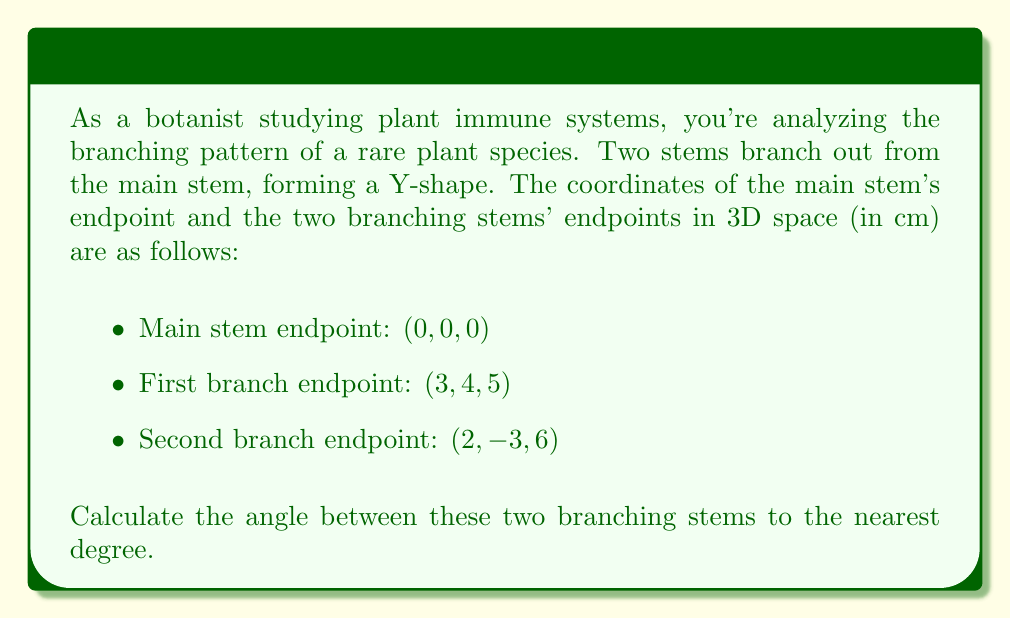Provide a solution to this math problem. To solve this problem, we'll follow these steps:

1) First, we need to find the vectors representing each branching stem. We can do this by subtracting the coordinates of the main stem endpoint from each branch endpoint:

   Vector 1: $\vec{v_1} = (3-0, 4-0, 5-0) = (3, 4, 5)$
   Vector 2: $\vec{v_2} = (2-0, -3-0, 6-0) = (2, -3, 6)$

2) The angle between two vectors can be calculated using the dot product formula:

   $$\cos \theta = \frac{\vec{v_1} \cdot \vec{v_2}}{|\vec{v_1}||\vec{v_2}|}$$

3) Let's calculate the dot product $\vec{v_1} \cdot \vec{v_2}$:
   
   $\vec{v_1} \cdot \vec{v_2} = (3)(2) + (4)(-3) + (5)(6) = 6 - 12 + 30 = 24$

4) Now we need to calculate the magnitudes of the vectors:

   $|\vec{v_1}| = \sqrt{3^2 + 4^2 + 5^2} = \sqrt{50}$
   $|\vec{v_2}| = \sqrt{2^2 + (-3)^2 + 6^2} = \sqrt{49} = 7$

5) Substituting into the formula:

   $$\cos \theta = \frac{24}{\sqrt{50} \cdot 7}$$

6) Simplify:
   
   $$\cos \theta = \frac{24}{7\sqrt{50}} = \frac{24}{7\sqrt{2} \cdot 5}$$

7) To find $\theta$, we take the inverse cosine (arccos) of both sides:

   $$\theta = \arccos(\frac{24}{7\sqrt{50}})$$

8) Using a calculator and rounding to the nearest degree:

   $\theta \approx 51°$
Answer: The angle between the two branching stems is approximately 51°. 